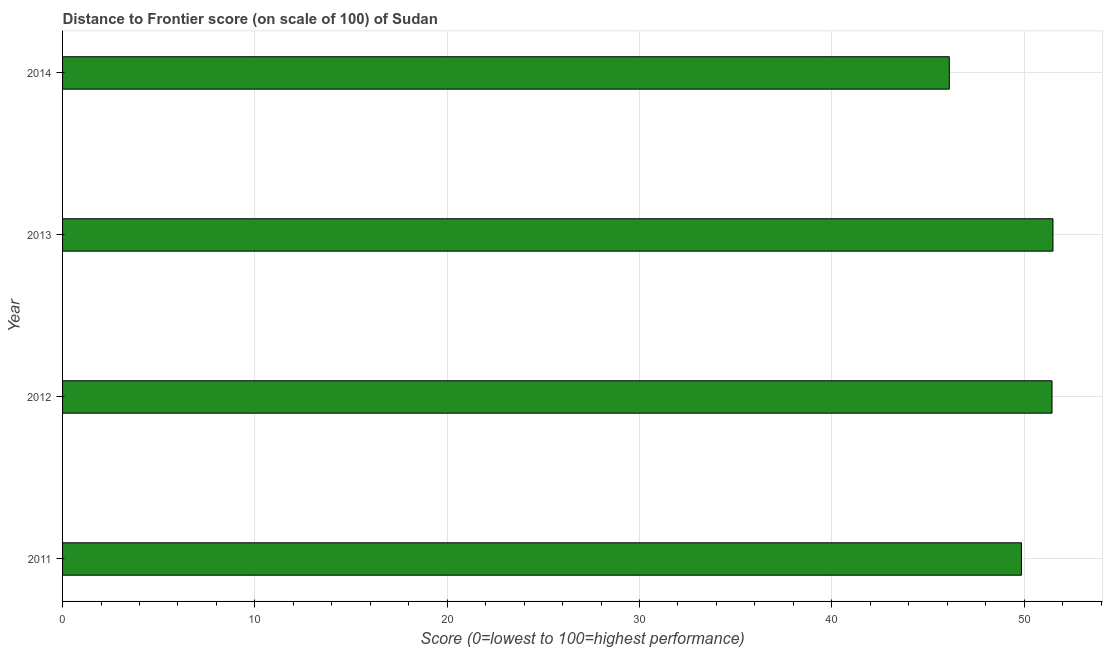Does the graph contain any zero values?
Make the answer very short. No. What is the title of the graph?
Your answer should be compact. Distance to Frontier score (on scale of 100) of Sudan. What is the label or title of the X-axis?
Offer a very short reply. Score (0=lowest to 100=highest performance). What is the label or title of the Y-axis?
Make the answer very short. Year. What is the distance to frontier score in 2013?
Your answer should be very brief. 51.5. Across all years, what is the maximum distance to frontier score?
Ensure brevity in your answer.  51.5. Across all years, what is the minimum distance to frontier score?
Provide a succinct answer. 46.11. In which year was the distance to frontier score minimum?
Keep it short and to the point. 2014. What is the sum of the distance to frontier score?
Give a very brief answer. 198.92. What is the difference between the distance to frontier score in 2011 and 2012?
Keep it short and to the point. -1.59. What is the average distance to frontier score per year?
Your answer should be compact. 49.73. What is the median distance to frontier score?
Your answer should be very brief. 50.66. Is the sum of the distance to frontier score in 2011 and 2012 greater than the maximum distance to frontier score across all years?
Make the answer very short. Yes. What is the difference between the highest and the lowest distance to frontier score?
Keep it short and to the point. 5.39. How many years are there in the graph?
Offer a terse response. 4. What is the difference between two consecutive major ticks on the X-axis?
Provide a succinct answer. 10. Are the values on the major ticks of X-axis written in scientific E-notation?
Ensure brevity in your answer.  No. What is the Score (0=lowest to 100=highest performance) in 2011?
Ensure brevity in your answer.  49.86. What is the Score (0=lowest to 100=highest performance) in 2012?
Offer a very short reply. 51.45. What is the Score (0=lowest to 100=highest performance) in 2013?
Keep it short and to the point. 51.5. What is the Score (0=lowest to 100=highest performance) of 2014?
Ensure brevity in your answer.  46.11. What is the difference between the Score (0=lowest to 100=highest performance) in 2011 and 2012?
Offer a very short reply. -1.59. What is the difference between the Score (0=lowest to 100=highest performance) in 2011 and 2013?
Provide a succinct answer. -1.64. What is the difference between the Score (0=lowest to 100=highest performance) in 2011 and 2014?
Ensure brevity in your answer.  3.75. What is the difference between the Score (0=lowest to 100=highest performance) in 2012 and 2014?
Your response must be concise. 5.34. What is the difference between the Score (0=lowest to 100=highest performance) in 2013 and 2014?
Ensure brevity in your answer.  5.39. What is the ratio of the Score (0=lowest to 100=highest performance) in 2011 to that in 2012?
Your response must be concise. 0.97. What is the ratio of the Score (0=lowest to 100=highest performance) in 2011 to that in 2013?
Offer a terse response. 0.97. What is the ratio of the Score (0=lowest to 100=highest performance) in 2011 to that in 2014?
Offer a terse response. 1.08. What is the ratio of the Score (0=lowest to 100=highest performance) in 2012 to that in 2014?
Provide a short and direct response. 1.12. What is the ratio of the Score (0=lowest to 100=highest performance) in 2013 to that in 2014?
Keep it short and to the point. 1.12. 